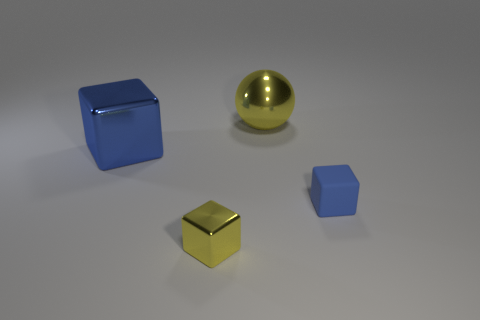Are there any other things that are the same color as the small matte cube?
Your answer should be very brief. Yes. There is a object that is the same color as the metallic ball; what material is it?
Your answer should be very brief. Metal. Are there any tiny matte objects that have the same color as the big block?
Provide a short and direct response. Yes. What number of things are either yellow metal objects or metal cubes behind the small rubber block?
Keep it short and to the point. 3. Is the number of blue rubber cubes in front of the tiny rubber cube less than the number of large red objects?
Offer a very short reply. No. What size is the yellow thing in front of the tiny object that is on the right side of the metallic sphere left of the matte object?
Give a very brief answer. Small. The metallic thing that is both behind the rubber block and on the left side of the ball is what color?
Your response must be concise. Blue. How many blue cubes are there?
Your answer should be very brief. 2. Are the large blue object and the big ball made of the same material?
Offer a terse response. Yes. There is a block to the right of the large sphere; does it have the same size as the yellow thing that is in front of the yellow ball?
Offer a terse response. Yes. 